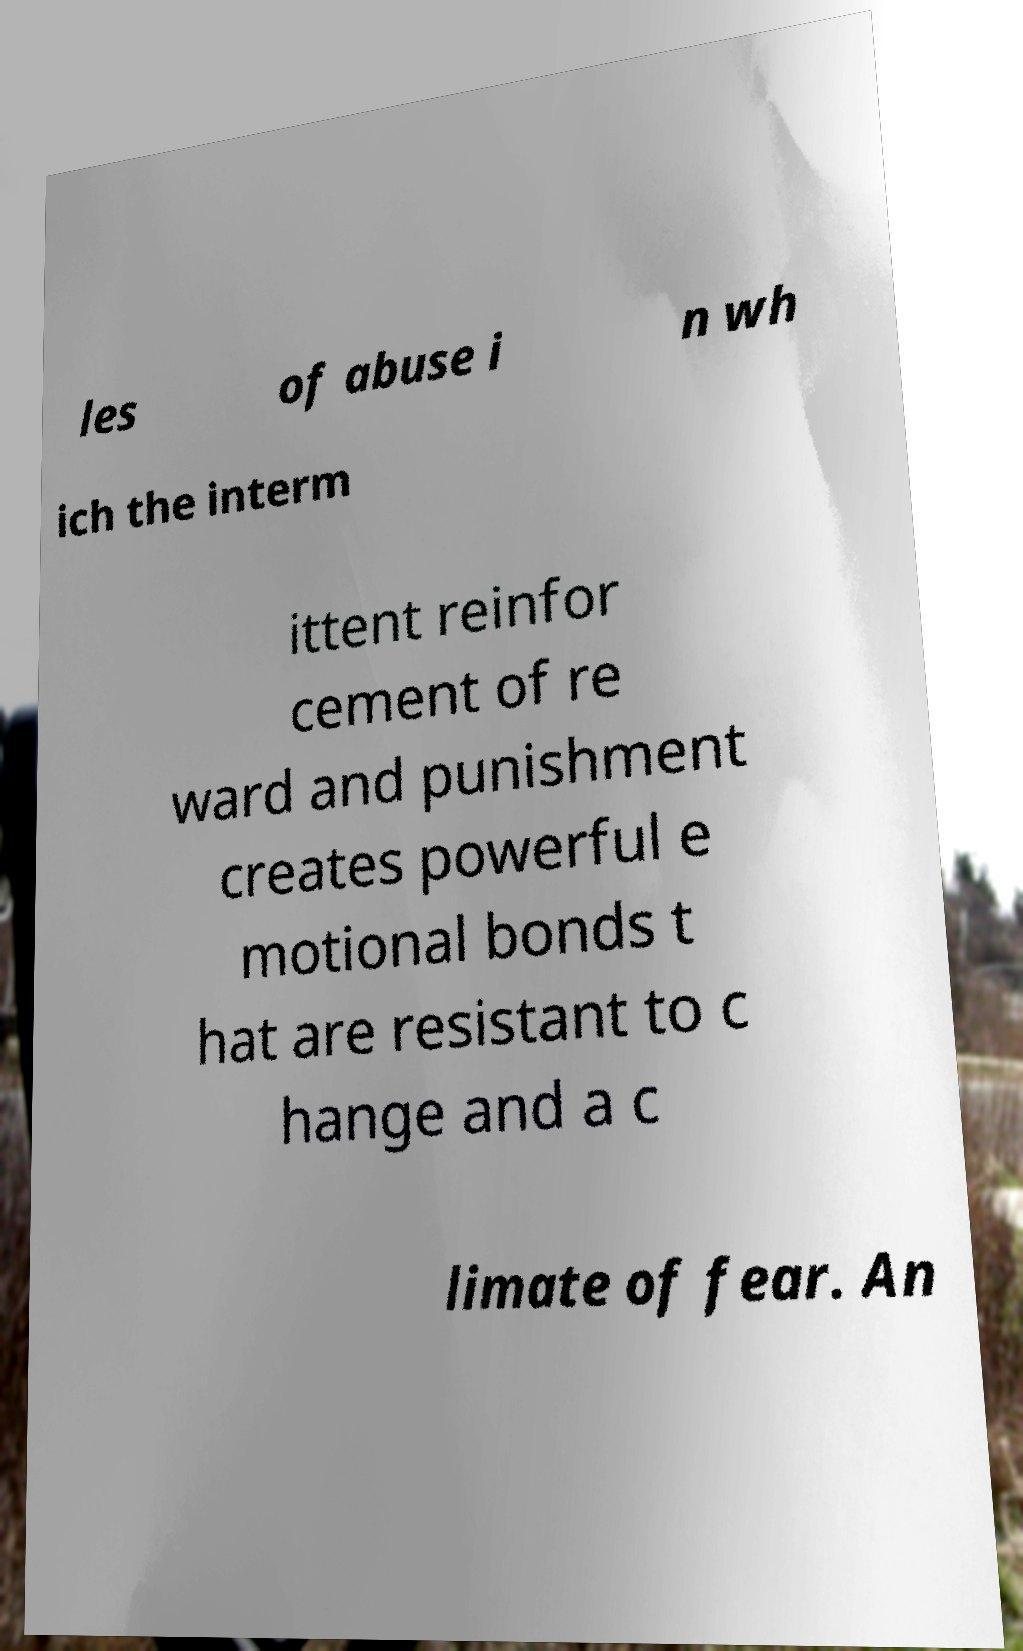Can you accurately transcribe the text from the provided image for me? les of abuse i n wh ich the interm ittent reinfor cement of re ward and punishment creates powerful e motional bonds t hat are resistant to c hange and a c limate of fear. An 